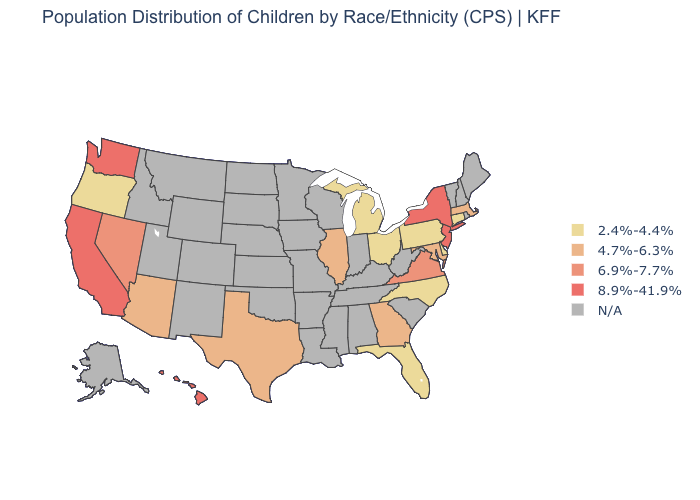Is the legend a continuous bar?
Give a very brief answer. No. Does the map have missing data?
Be succinct. Yes. Name the states that have a value in the range 8.9%-41.9%?
Quick response, please. California, Hawaii, New Jersey, New York, Washington. Name the states that have a value in the range N/A?
Answer briefly. Alabama, Alaska, Arkansas, Colorado, Idaho, Indiana, Iowa, Kansas, Kentucky, Louisiana, Maine, Minnesota, Mississippi, Missouri, Montana, Nebraska, New Hampshire, New Mexico, North Dakota, Oklahoma, Rhode Island, South Carolina, South Dakota, Tennessee, Utah, Vermont, West Virginia, Wisconsin, Wyoming. Does the first symbol in the legend represent the smallest category?
Short answer required. Yes. Name the states that have a value in the range 4.7%-6.3%?
Keep it brief. Arizona, Georgia, Illinois, Maryland, Massachusetts, Texas. Which states hav the highest value in the MidWest?
Be succinct. Illinois. Does Illinois have the lowest value in the USA?
Give a very brief answer. No. Does Florida have the lowest value in the South?
Quick response, please. Yes. What is the value of Vermont?
Be succinct. N/A. Among the states that border New Mexico , which have the highest value?
Give a very brief answer. Arizona, Texas. 